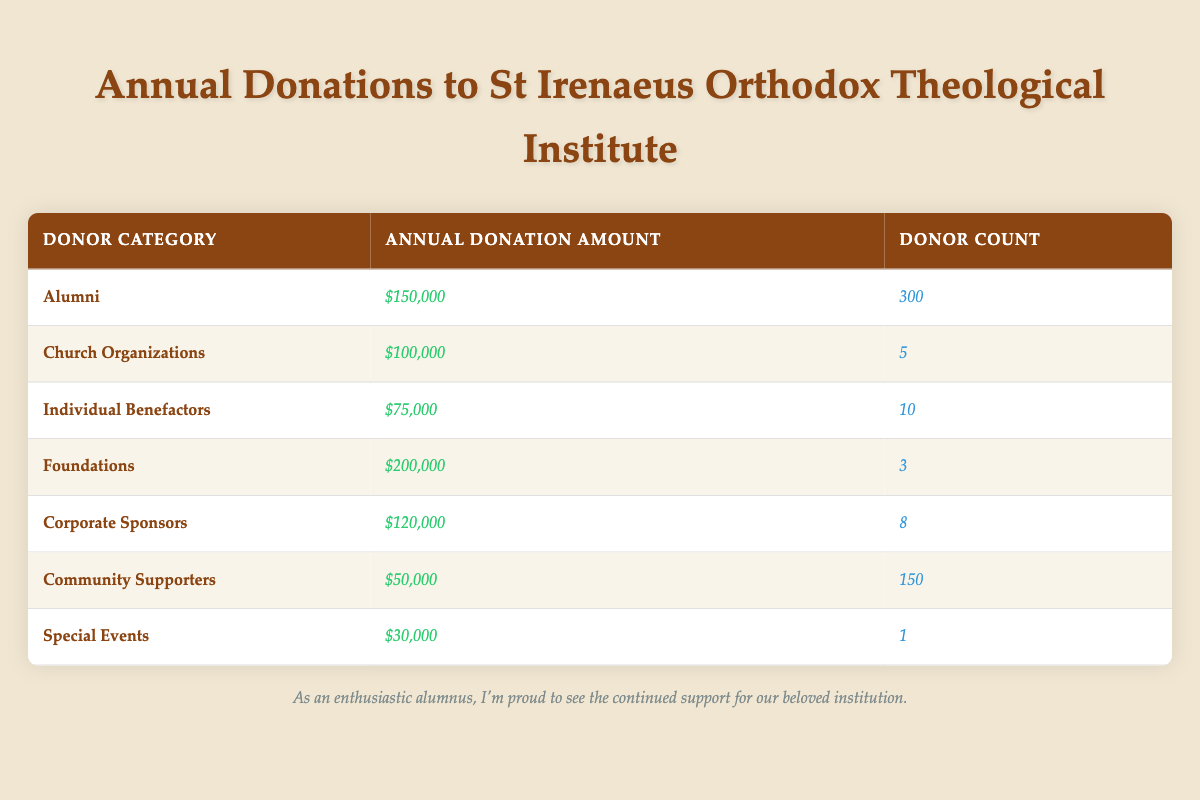What is the total annual donation amount received from Alumni? The annual donation amount for Alumni is $150,000 as per the table.
Answer: $150,000 How many Corporate Sponsors have donated to the Institute? The table indicates that there are 8 Corporate Sponsors who have made donations.
Answer: 8 Which donor category received the highest annual donation amount? The Foundations category received the highest amount of $200,000 according to the data presented in the table.
Answer: Foundations What is the combined annual donation amount from Community Supporters and Individual Benefactors? Community Supporters contributed $50,000 and Individual Benefactors contributed $75,000. The sum is $50,000 + $75,000 = $125,000.
Answer: $125,000 Is the annual donation amount from Church Organizations more than that from Individual Benefactors? The Church Organizations donated $100,000 while Individual Benefactors donated $75,000. Therefore, yes, Church Organizations donated more.
Answer: Yes What is the average annual donation amount across all donor categories? To find the average, sum all annual donations: $150,000 + $100,000 + $75,000 + $200,000 + $120,000 + $50,000 + $30,000 = $725,000, and divide by 7 (the number of categories): 725,000 / 7 = $103,571.43.
Answer: $103,571.43 If we exclude the amount received from Special Events, what would be the total of annual donations? Special Events contributed $30,000, so we need to subtract this from the total: $725,000 - $30,000 = $695,000.
Answer: $695,000 How many total donors are represented in the table? To find total donors, add the donor counts: 300 (Alumni) + 5 (Church Organizations) + 10 (Individual Benefactors) + 3 (Foundations) + 8 (Corporate Sponsors) + 150 (Community Supporters) + 1 (Special Events) = 477.
Answer: 477 Which donor category has the lowest annual donation amount? The Community Supporters category received the lowest donation of $50,000 as represented in the table.
Answer: Community Supporters What ratio of total donations comes from Foundations to the total donations? Foundations donated $200,000. The total is $725,000. The ratio is 200,000 / 725,000 = 0.275, or approximately 27.5%.
Answer: 27.5% How many more donations (in count) do Alumni have compared to Special Events? Alumni count is 300 and Special Events count is 1. The difference is 300 - 1 = 299.
Answer: 299 